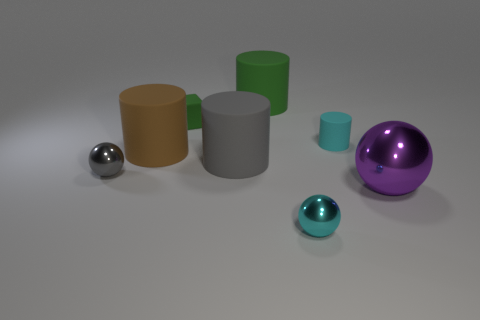Add 1 large cyan matte things. How many objects exist? 9 Subtract all gray balls. How many balls are left? 2 Subtract all purple balls. How many balls are left? 2 Subtract 2 cylinders. How many cylinders are left? 2 Subtract all cyan balls. How many brown cylinders are left? 1 Subtract all cyan things. Subtract all red rubber cubes. How many objects are left? 6 Add 2 big gray objects. How many big gray objects are left? 3 Add 3 small rubber objects. How many small rubber objects exist? 5 Subtract 0 brown cubes. How many objects are left? 8 Subtract all balls. How many objects are left? 5 